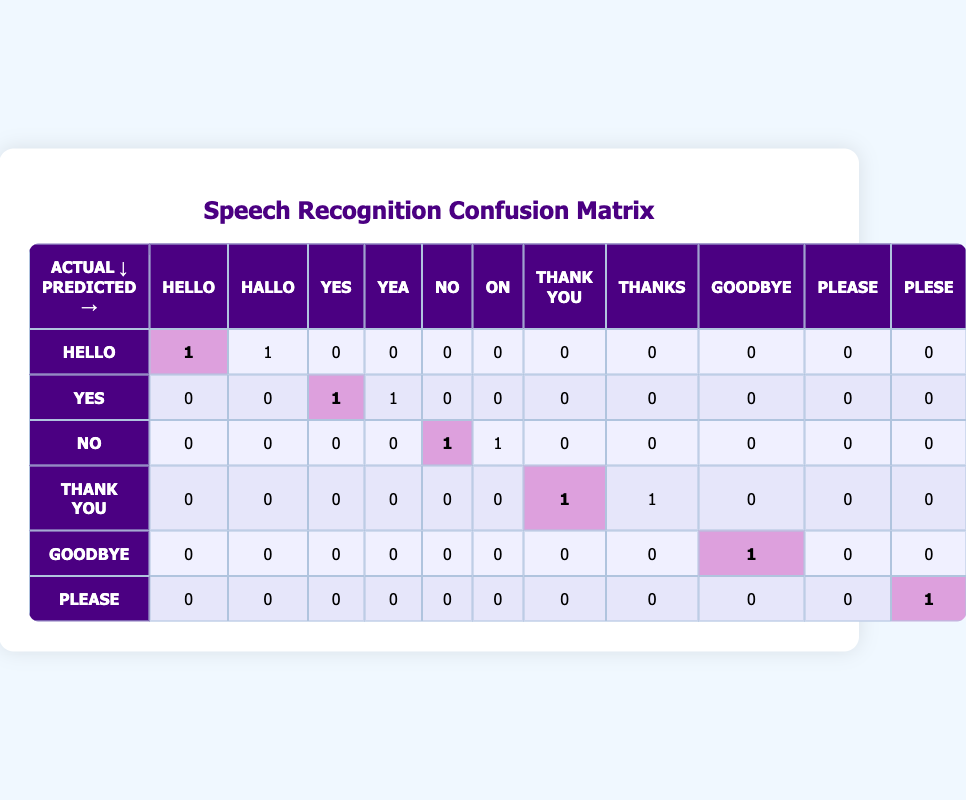What is the number of correct predictions for the phrase "hello"? Referring to the row for "hello," we see one correct prediction (the actual "hello" predicted as "hello") and one incorrect prediction (the actual "hello" predicted as "hallo"). The correct predictions count is marked in the table.
Answer: 1 How many total predictions were made for the phrase "yes"? Looking at the row for "yes," we can see two predictions: one is correct (predicted as "yes") and one is incorrect (predicted as "yea"). To find the total, we count these two values together: 1 + 1 = 2.
Answer: 2 Is the phrase "thank you" predicted incorrectly more than once? Checking the row for "thank you," there are two predictions listed: one is correct ("thank you") and one is incorrect ("thanks"). Thus, there is only one incorrect prediction, which is less than two.
Answer: No What is the total number of incorrect predictions across all phrases? To find the total of incorrect predictions, we need to assess each row. Incorrect predictions: "hello" (1), "yes" (1), "no" (1), "thank you" (1), "goodbye" (0), and "please" (1). Summing these gives: 1 + 1 + 1 + 1 + 0 + 1 = 5.
Answer: 5 Which phrase has the highest number of incorrect predictions? Examining the rows, the phrases "hello," "yes," "no," and "thank you" each show one incorrect prediction. The phrases "goodbye" and "please" show none. So, multiple phrases share the highest count of incorrect predictions at one.
Answer: "hello," "yes," "no," "thank you" How many predictions did the model make for phrases that it had not seen during training? The table shows how the model classified inputs, including correct and incorrect predictions. Every phrase ("hello," "yes," "no," "thank you," "goodbye," and "please") had at least one prediction. Since all phrases had predictions and no entries for unseen phrases, the answer is that it did not generate predictions for any unknown phrases.
Answer: 0 What is the average number of predictions made per phrase? To compute this, we first identify how many phrases there are, which is 6. The total number of predictions is computed by summing all predictions: "hello" (2), "yes" (2), "no" (2), "thank you" (2), "goodbye" (1), "please" (1) = 10. Then, we divide this by the total phrases: 10 / 6 ≈ 1.67.
Answer: Approximately 1.67 Did the model get the phrase "please" correctly? Taking a clearer look at the row for "please," it shows one instance of "plese," which is incorrect. Hence, since no correct matches were noted, the answer can be easily drawn.
Answer: No 